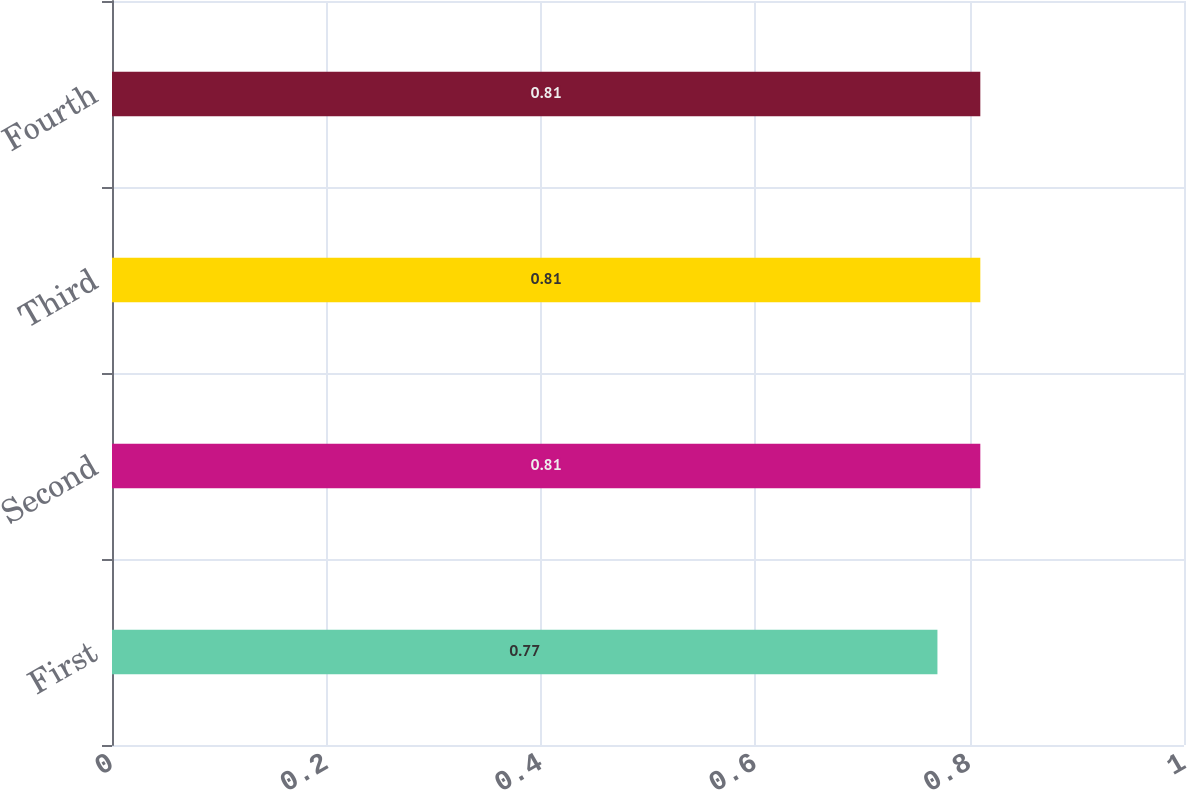Convert chart. <chart><loc_0><loc_0><loc_500><loc_500><bar_chart><fcel>First<fcel>Second<fcel>Third<fcel>Fourth<nl><fcel>0.77<fcel>0.81<fcel>0.81<fcel>0.81<nl></chart> 